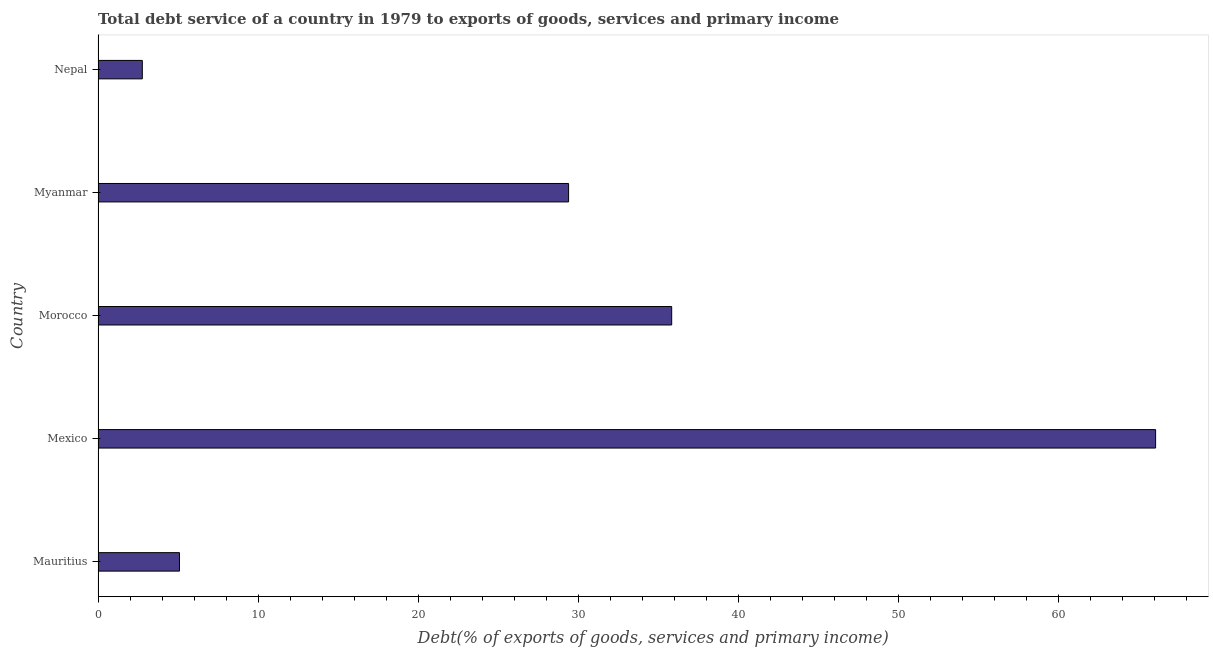What is the title of the graph?
Provide a short and direct response. Total debt service of a country in 1979 to exports of goods, services and primary income. What is the label or title of the X-axis?
Keep it short and to the point. Debt(% of exports of goods, services and primary income). What is the total debt service in Mexico?
Your answer should be very brief. 66.07. Across all countries, what is the maximum total debt service?
Your answer should be very brief. 66.07. Across all countries, what is the minimum total debt service?
Offer a terse response. 2.76. In which country was the total debt service maximum?
Your answer should be very brief. Mexico. In which country was the total debt service minimum?
Ensure brevity in your answer.  Nepal. What is the sum of the total debt service?
Provide a short and direct response. 139.15. What is the difference between the total debt service in Morocco and Nepal?
Ensure brevity in your answer.  33.07. What is the average total debt service per country?
Offer a terse response. 27.83. What is the median total debt service?
Offer a terse response. 29.4. What is the ratio of the total debt service in Mexico to that in Myanmar?
Provide a short and direct response. 2.25. Is the difference between the total debt service in Morocco and Myanmar greater than the difference between any two countries?
Offer a terse response. No. What is the difference between the highest and the second highest total debt service?
Offer a very short reply. 30.23. Is the sum of the total debt service in Mexico and Morocco greater than the maximum total debt service across all countries?
Your answer should be compact. Yes. What is the difference between the highest and the lowest total debt service?
Your answer should be compact. 63.3. How many bars are there?
Give a very brief answer. 5. What is the difference between two consecutive major ticks on the X-axis?
Offer a terse response. 10. What is the Debt(% of exports of goods, services and primary income) in Mauritius?
Give a very brief answer. 5.09. What is the Debt(% of exports of goods, services and primary income) of Mexico?
Offer a terse response. 66.07. What is the Debt(% of exports of goods, services and primary income) of Morocco?
Make the answer very short. 35.84. What is the Debt(% of exports of goods, services and primary income) of Myanmar?
Your answer should be very brief. 29.4. What is the Debt(% of exports of goods, services and primary income) of Nepal?
Provide a short and direct response. 2.76. What is the difference between the Debt(% of exports of goods, services and primary income) in Mauritius and Mexico?
Make the answer very short. -60.98. What is the difference between the Debt(% of exports of goods, services and primary income) in Mauritius and Morocco?
Provide a short and direct response. -30.75. What is the difference between the Debt(% of exports of goods, services and primary income) in Mauritius and Myanmar?
Your answer should be compact. -24.31. What is the difference between the Debt(% of exports of goods, services and primary income) in Mauritius and Nepal?
Provide a succinct answer. 2.32. What is the difference between the Debt(% of exports of goods, services and primary income) in Mexico and Morocco?
Make the answer very short. 30.23. What is the difference between the Debt(% of exports of goods, services and primary income) in Mexico and Myanmar?
Your answer should be very brief. 36.67. What is the difference between the Debt(% of exports of goods, services and primary income) in Mexico and Nepal?
Provide a short and direct response. 63.3. What is the difference between the Debt(% of exports of goods, services and primary income) in Morocco and Myanmar?
Your answer should be compact. 6.44. What is the difference between the Debt(% of exports of goods, services and primary income) in Morocco and Nepal?
Your answer should be very brief. 33.07. What is the difference between the Debt(% of exports of goods, services and primary income) in Myanmar and Nepal?
Give a very brief answer. 26.63. What is the ratio of the Debt(% of exports of goods, services and primary income) in Mauritius to that in Mexico?
Offer a terse response. 0.08. What is the ratio of the Debt(% of exports of goods, services and primary income) in Mauritius to that in Morocco?
Your answer should be very brief. 0.14. What is the ratio of the Debt(% of exports of goods, services and primary income) in Mauritius to that in Myanmar?
Your answer should be very brief. 0.17. What is the ratio of the Debt(% of exports of goods, services and primary income) in Mauritius to that in Nepal?
Keep it short and to the point. 1.84. What is the ratio of the Debt(% of exports of goods, services and primary income) in Mexico to that in Morocco?
Make the answer very short. 1.84. What is the ratio of the Debt(% of exports of goods, services and primary income) in Mexico to that in Myanmar?
Your response must be concise. 2.25. What is the ratio of the Debt(% of exports of goods, services and primary income) in Mexico to that in Nepal?
Provide a succinct answer. 23.89. What is the ratio of the Debt(% of exports of goods, services and primary income) in Morocco to that in Myanmar?
Provide a succinct answer. 1.22. What is the ratio of the Debt(% of exports of goods, services and primary income) in Morocco to that in Nepal?
Give a very brief answer. 12.96. What is the ratio of the Debt(% of exports of goods, services and primary income) in Myanmar to that in Nepal?
Make the answer very short. 10.63. 